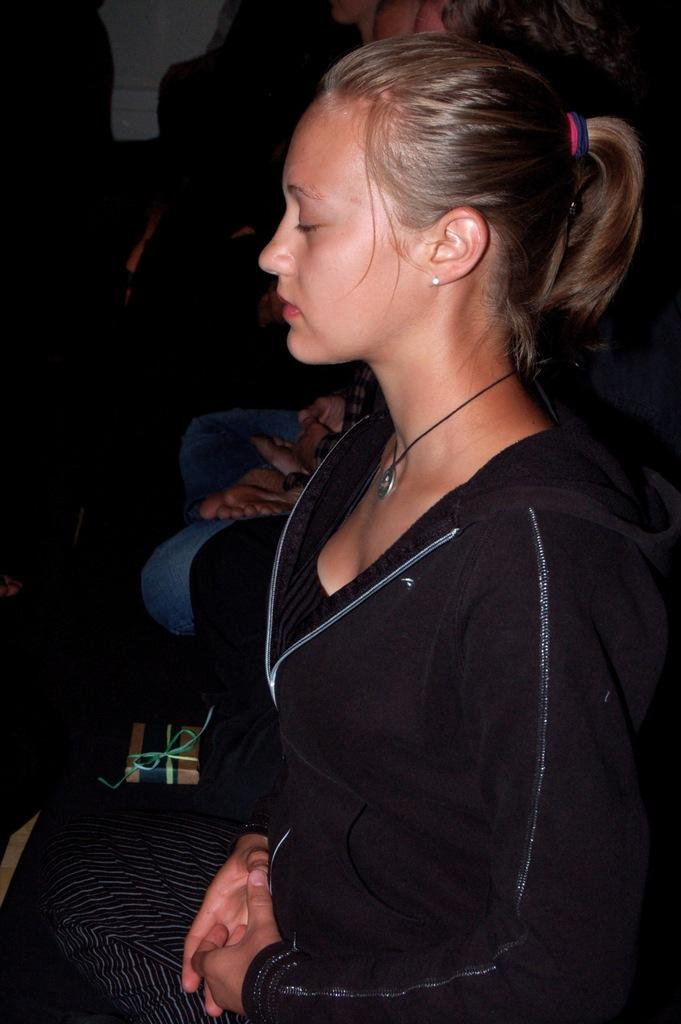What are the people in the image doing? The people in the image are sitting. What object can be seen with a ribbon in the image? There is a small gift box with a ribbon in the image. What type of stitch is used to create the ribbon on the gift box in the image? There is no information about the type of stitch used on the ribbon in the image. 